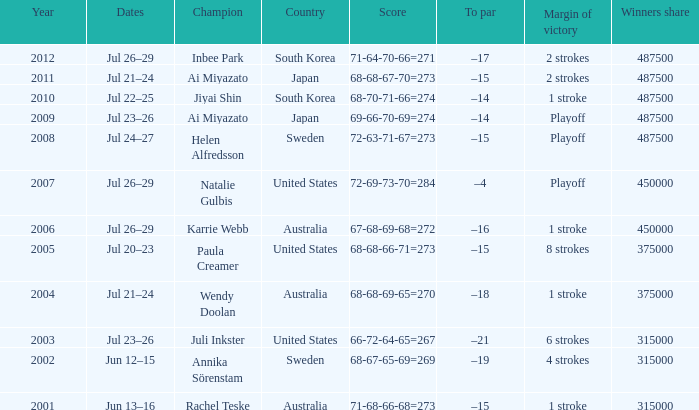How many years was Jiyai Shin the champion? 1.0. 